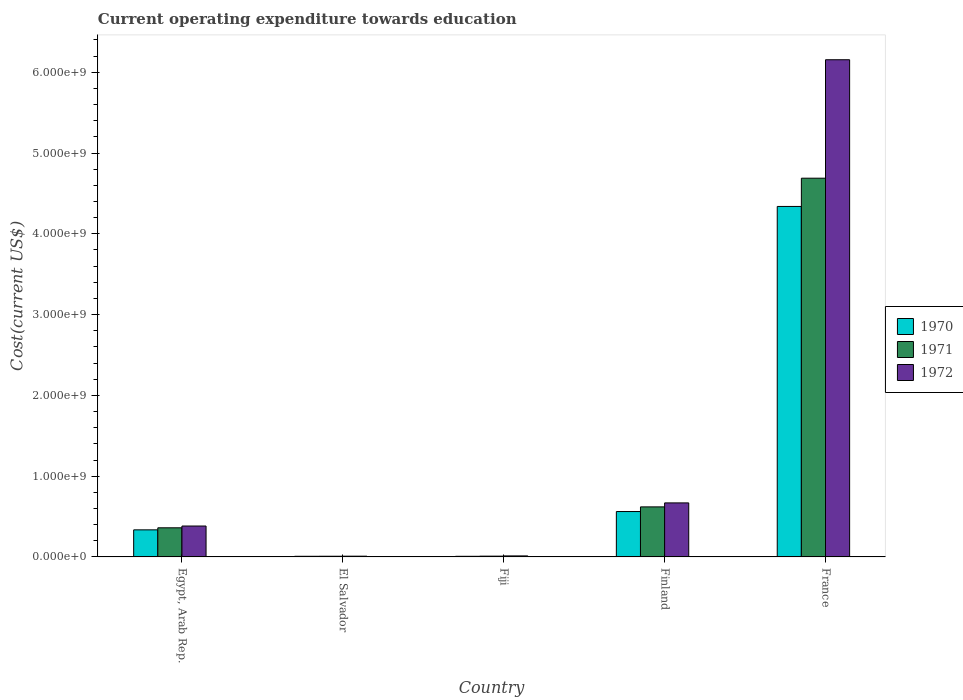How many different coloured bars are there?
Provide a short and direct response. 3. Are the number of bars on each tick of the X-axis equal?
Your answer should be very brief. Yes. What is the label of the 3rd group of bars from the left?
Offer a very short reply. Fiji. In how many cases, is the number of bars for a given country not equal to the number of legend labels?
Keep it short and to the point. 0. What is the expenditure towards education in 1970 in Fiji?
Provide a short and direct response. 7.79e+06. Across all countries, what is the maximum expenditure towards education in 1972?
Ensure brevity in your answer.  6.16e+09. Across all countries, what is the minimum expenditure towards education in 1972?
Give a very brief answer. 9.26e+06. In which country was the expenditure towards education in 1971 minimum?
Your response must be concise. El Salvador. What is the total expenditure towards education in 1972 in the graph?
Ensure brevity in your answer.  7.23e+09. What is the difference between the expenditure towards education in 1970 in Egypt, Arab Rep. and that in France?
Offer a very short reply. -4.00e+09. What is the difference between the expenditure towards education in 1972 in France and the expenditure towards education in 1970 in Finland?
Provide a short and direct response. 5.59e+09. What is the average expenditure towards education in 1970 per country?
Keep it short and to the point. 1.05e+09. What is the difference between the expenditure towards education of/in 1972 and expenditure towards education of/in 1971 in Fiji?
Offer a terse response. 2.95e+06. What is the ratio of the expenditure towards education in 1970 in Finland to that in France?
Your response must be concise. 0.13. What is the difference between the highest and the second highest expenditure towards education in 1970?
Provide a short and direct response. 3.78e+09. What is the difference between the highest and the lowest expenditure towards education in 1971?
Offer a terse response. 4.68e+09. In how many countries, is the expenditure towards education in 1972 greater than the average expenditure towards education in 1972 taken over all countries?
Your answer should be compact. 1. Is the sum of the expenditure towards education in 1972 in Finland and France greater than the maximum expenditure towards education in 1970 across all countries?
Make the answer very short. Yes. What does the 1st bar from the left in Egypt, Arab Rep. represents?
Your response must be concise. 1970. Is it the case that in every country, the sum of the expenditure towards education in 1970 and expenditure towards education in 1971 is greater than the expenditure towards education in 1972?
Keep it short and to the point. Yes. How many bars are there?
Offer a very short reply. 15. What is the difference between two consecutive major ticks on the Y-axis?
Your answer should be very brief. 1.00e+09. Are the values on the major ticks of Y-axis written in scientific E-notation?
Ensure brevity in your answer.  Yes. Does the graph contain grids?
Provide a short and direct response. No. Where does the legend appear in the graph?
Your answer should be very brief. Center right. What is the title of the graph?
Make the answer very short. Current operating expenditure towards education. What is the label or title of the Y-axis?
Give a very brief answer. Cost(current US$). What is the Cost(current US$) in 1970 in Egypt, Arab Rep.?
Give a very brief answer. 3.35e+08. What is the Cost(current US$) of 1971 in Egypt, Arab Rep.?
Keep it short and to the point. 3.60e+08. What is the Cost(current US$) in 1972 in Egypt, Arab Rep.?
Provide a succinct answer. 3.83e+08. What is the Cost(current US$) of 1970 in El Salvador?
Your response must be concise. 7.86e+06. What is the Cost(current US$) of 1971 in El Salvador?
Offer a terse response. 8.46e+06. What is the Cost(current US$) in 1972 in El Salvador?
Keep it short and to the point. 9.26e+06. What is the Cost(current US$) of 1970 in Fiji?
Keep it short and to the point. 7.79e+06. What is the Cost(current US$) of 1971 in Fiji?
Provide a succinct answer. 9.67e+06. What is the Cost(current US$) in 1972 in Fiji?
Make the answer very short. 1.26e+07. What is the Cost(current US$) of 1970 in Finland?
Make the answer very short. 5.62e+08. What is the Cost(current US$) in 1971 in Finland?
Make the answer very short. 6.20e+08. What is the Cost(current US$) of 1972 in Finland?
Your answer should be very brief. 6.69e+08. What is the Cost(current US$) in 1970 in France?
Offer a very short reply. 4.34e+09. What is the Cost(current US$) of 1971 in France?
Provide a short and direct response. 4.69e+09. What is the Cost(current US$) of 1972 in France?
Keep it short and to the point. 6.16e+09. Across all countries, what is the maximum Cost(current US$) of 1970?
Provide a succinct answer. 4.34e+09. Across all countries, what is the maximum Cost(current US$) of 1971?
Make the answer very short. 4.69e+09. Across all countries, what is the maximum Cost(current US$) of 1972?
Give a very brief answer. 6.16e+09. Across all countries, what is the minimum Cost(current US$) in 1970?
Provide a short and direct response. 7.79e+06. Across all countries, what is the minimum Cost(current US$) in 1971?
Your answer should be compact. 8.46e+06. Across all countries, what is the minimum Cost(current US$) of 1972?
Offer a terse response. 9.26e+06. What is the total Cost(current US$) in 1970 in the graph?
Offer a terse response. 5.25e+09. What is the total Cost(current US$) of 1971 in the graph?
Provide a short and direct response. 5.69e+09. What is the total Cost(current US$) of 1972 in the graph?
Offer a very short reply. 7.23e+09. What is the difference between the Cost(current US$) in 1970 in Egypt, Arab Rep. and that in El Salvador?
Make the answer very short. 3.27e+08. What is the difference between the Cost(current US$) in 1971 in Egypt, Arab Rep. and that in El Salvador?
Make the answer very short. 3.52e+08. What is the difference between the Cost(current US$) in 1972 in Egypt, Arab Rep. and that in El Salvador?
Keep it short and to the point. 3.73e+08. What is the difference between the Cost(current US$) of 1970 in Egypt, Arab Rep. and that in Fiji?
Your answer should be very brief. 3.27e+08. What is the difference between the Cost(current US$) of 1971 in Egypt, Arab Rep. and that in Fiji?
Give a very brief answer. 3.51e+08. What is the difference between the Cost(current US$) in 1972 in Egypt, Arab Rep. and that in Fiji?
Provide a short and direct response. 3.70e+08. What is the difference between the Cost(current US$) of 1970 in Egypt, Arab Rep. and that in Finland?
Your response must be concise. -2.27e+08. What is the difference between the Cost(current US$) of 1971 in Egypt, Arab Rep. and that in Finland?
Offer a terse response. -2.59e+08. What is the difference between the Cost(current US$) in 1972 in Egypt, Arab Rep. and that in Finland?
Offer a terse response. -2.86e+08. What is the difference between the Cost(current US$) of 1970 in Egypt, Arab Rep. and that in France?
Give a very brief answer. -4.00e+09. What is the difference between the Cost(current US$) in 1971 in Egypt, Arab Rep. and that in France?
Your answer should be very brief. -4.33e+09. What is the difference between the Cost(current US$) in 1972 in Egypt, Arab Rep. and that in France?
Your answer should be very brief. -5.77e+09. What is the difference between the Cost(current US$) of 1970 in El Salvador and that in Fiji?
Offer a very short reply. 7.56e+04. What is the difference between the Cost(current US$) of 1971 in El Salvador and that in Fiji?
Your response must be concise. -1.21e+06. What is the difference between the Cost(current US$) in 1972 in El Salvador and that in Fiji?
Ensure brevity in your answer.  -3.37e+06. What is the difference between the Cost(current US$) of 1970 in El Salvador and that in Finland?
Your answer should be very brief. -5.54e+08. What is the difference between the Cost(current US$) in 1971 in El Salvador and that in Finland?
Make the answer very short. -6.11e+08. What is the difference between the Cost(current US$) in 1972 in El Salvador and that in Finland?
Your answer should be very brief. -6.60e+08. What is the difference between the Cost(current US$) of 1970 in El Salvador and that in France?
Your answer should be compact. -4.33e+09. What is the difference between the Cost(current US$) of 1971 in El Salvador and that in France?
Your answer should be very brief. -4.68e+09. What is the difference between the Cost(current US$) in 1972 in El Salvador and that in France?
Your answer should be very brief. -6.15e+09. What is the difference between the Cost(current US$) of 1970 in Fiji and that in Finland?
Make the answer very short. -5.54e+08. What is the difference between the Cost(current US$) in 1971 in Fiji and that in Finland?
Ensure brevity in your answer.  -6.10e+08. What is the difference between the Cost(current US$) in 1972 in Fiji and that in Finland?
Ensure brevity in your answer.  -6.56e+08. What is the difference between the Cost(current US$) of 1970 in Fiji and that in France?
Keep it short and to the point. -4.33e+09. What is the difference between the Cost(current US$) in 1971 in Fiji and that in France?
Ensure brevity in your answer.  -4.68e+09. What is the difference between the Cost(current US$) of 1972 in Fiji and that in France?
Your answer should be very brief. -6.14e+09. What is the difference between the Cost(current US$) of 1970 in Finland and that in France?
Provide a succinct answer. -3.78e+09. What is the difference between the Cost(current US$) of 1971 in Finland and that in France?
Provide a short and direct response. -4.07e+09. What is the difference between the Cost(current US$) in 1972 in Finland and that in France?
Ensure brevity in your answer.  -5.49e+09. What is the difference between the Cost(current US$) in 1970 in Egypt, Arab Rep. and the Cost(current US$) in 1971 in El Salvador?
Keep it short and to the point. 3.27e+08. What is the difference between the Cost(current US$) of 1970 in Egypt, Arab Rep. and the Cost(current US$) of 1972 in El Salvador?
Provide a succinct answer. 3.26e+08. What is the difference between the Cost(current US$) in 1971 in Egypt, Arab Rep. and the Cost(current US$) in 1972 in El Salvador?
Keep it short and to the point. 3.51e+08. What is the difference between the Cost(current US$) of 1970 in Egypt, Arab Rep. and the Cost(current US$) of 1971 in Fiji?
Make the answer very short. 3.26e+08. What is the difference between the Cost(current US$) of 1970 in Egypt, Arab Rep. and the Cost(current US$) of 1972 in Fiji?
Make the answer very short. 3.23e+08. What is the difference between the Cost(current US$) of 1971 in Egypt, Arab Rep. and the Cost(current US$) of 1972 in Fiji?
Provide a succinct answer. 3.48e+08. What is the difference between the Cost(current US$) in 1970 in Egypt, Arab Rep. and the Cost(current US$) in 1971 in Finland?
Keep it short and to the point. -2.84e+08. What is the difference between the Cost(current US$) of 1970 in Egypt, Arab Rep. and the Cost(current US$) of 1972 in Finland?
Provide a succinct answer. -3.34e+08. What is the difference between the Cost(current US$) of 1971 in Egypt, Arab Rep. and the Cost(current US$) of 1972 in Finland?
Your answer should be compact. -3.08e+08. What is the difference between the Cost(current US$) of 1970 in Egypt, Arab Rep. and the Cost(current US$) of 1971 in France?
Provide a succinct answer. -4.35e+09. What is the difference between the Cost(current US$) in 1970 in Egypt, Arab Rep. and the Cost(current US$) in 1972 in France?
Give a very brief answer. -5.82e+09. What is the difference between the Cost(current US$) in 1971 in Egypt, Arab Rep. and the Cost(current US$) in 1972 in France?
Your answer should be compact. -5.79e+09. What is the difference between the Cost(current US$) in 1970 in El Salvador and the Cost(current US$) in 1971 in Fiji?
Ensure brevity in your answer.  -1.81e+06. What is the difference between the Cost(current US$) in 1970 in El Salvador and the Cost(current US$) in 1972 in Fiji?
Provide a succinct answer. -4.76e+06. What is the difference between the Cost(current US$) of 1971 in El Salvador and the Cost(current US$) of 1972 in Fiji?
Ensure brevity in your answer.  -4.16e+06. What is the difference between the Cost(current US$) of 1970 in El Salvador and the Cost(current US$) of 1971 in Finland?
Your answer should be very brief. -6.12e+08. What is the difference between the Cost(current US$) in 1970 in El Salvador and the Cost(current US$) in 1972 in Finland?
Your answer should be very brief. -6.61e+08. What is the difference between the Cost(current US$) in 1971 in El Salvador and the Cost(current US$) in 1972 in Finland?
Provide a short and direct response. -6.60e+08. What is the difference between the Cost(current US$) in 1970 in El Salvador and the Cost(current US$) in 1971 in France?
Keep it short and to the point. -4.68e+09. What is the difference between the Cost(current US$) of 1970 in El Salvador and the Cost(current US$) of 1972 in France?
Offer a terse response. -6.15e+09. What is the difference between the Cost(current US$) in 1971 in El Salvador and the Cost(current US$) in 1972 in France?
Make the answer very short. -6.15e+09. What is the difference between the Cost(current US$) of 1970 in Fiji and the Cost(current US$) of 1971 in Finland?
Provide a short and direct response. -6.12e+08. What is the difference between the Cost(current US$) of 1970 in Fiji and the Cost(current US$) of 1972 in Finland?
Offer a terse response. -6.61e+08. What is the difference between the Cost(current US$) of 1971 in Fiji and the Cost(current US$) of 1972 in Finland?
Make the answer very short. -6.59e+08. What is the difference between the Cost(current US$) of 1970 in Fiji and the Cost(current US$) of 1971 in France?
Offer a very short reply. -4.68e+09. What is the difference between the Cost(current US$) of 1970 in Fiji and the Cost(current US$) of 1972 in France?
Your response must be concise. -6.15e+09. What is the difference between the Cost(current US$) in 1971 in Fiji and the Cost(current US$) in 1972 in France?
Your answer should be compact. -6.15e+09. What is the difference between the Cost(current US$) of 1970 in Finland and the Cost(current US$) of 1971 in France?
Your response must be concise. -4.13e+09. What is the difference between the Cost(current US$) in 1970 in Finland and the Cost(current US$) in 1972 in France?
Provide a short and direct response. -5.59e+09. What is the difference between the Cost(current US$) in 1971 in Finland and the Cost(current US$) in 1972 in France?
Keep it short and to the point. -5.54e+09. What is the average Cost(current US$) in 1970 per country?
Your answer should be very brief. 1.05e+09. What is the average Cost(current US$) of 1971 per country?
Offer a very short reply. 1.14e+09. What is the average Cost(current US$) of 1972 per country?
Offer a terse response. 1.45e+09. What is the difference between the Cost(current US$) of 1970 and Cost(current US$) of 1971 in Egypt, Arab Rep.?
Your answer should be very brief. -2.53e+07. What is the difference between the Cost(current US$) of 1970 and Cost(current US$) of 1972 in Egypt, Arab Rep.?
Your response must be concise. -4.74e+07. What is the difference between the Cost(current US$) in 1971 and Cost(current US$) in 1972 in Egypt, Arab Rep.?
Ensure brevity in your answer.  -2.21e+07. What is the difference between the Cost(current US$) of 1970 and Cost(current US$) of 1971 in El Salvador?
Your response must be concise. -6.00e+05. What is the difference between the Cost(current US$) of 1970 and Cost(current US$) of 1972 in El Salvador?
Give a very brief answer. -1.39e+06. What is the difference between the Cost(current US$) in 1971 and Cost(current US$) in 1972 in El Salvador?
Your response must be concise. -7.94e+05. What is the difference between the Cost(current US$) in 1970 and Cost(current US$) in 1971 in Fiji?
Your response must be concise. -1.89e+06. What is the difference between the Cost(current US$) of 1970 and Cost(current US$) of 1972 in Fiji?
Your response must be concise. -4.84e+06. What is the difference between the Cost(current US$) of 1971 and Cost(current US$) of 1972 in Fiji?
Your response must be concise. -2.95e+06. What is the difference between the Cost(current US$) of 1970 and Cost(current US$) of 1971 in Finland?
Give a very brief answer. -5.76e+07. What is the difference between the Cost(current US$) in 1970 and Cost(current US$) in 1972 in Finland?
Provide a succinct answer. -1.07e+08. What is the difference between the Cost(current US$) in 1971 and Cost(current US$) in 1972 in Finland?
Your answer should be very brief. -4.93e+07. What is the difference between the Cost(current US$) of 1970 and Cost(current US$) of 1971 in France?
Give a very brief answer. -3.50e+08. What is the difference between the Cost(current US$) in 1970 and Cost(current US$) in 1972 in France?
Your response must be concise. -1.82e+09. What is the difference between the Cost(current US$) of 1971 and Cost(current US$) of 1972 in France?
Keep it short and to the point. -1.47e+09. What is the ratio of the Cost(current US$) of 1970 in Egypt, Arab Rep. to that in El Salvador?
Ensure brevity in your answer.  42.63. What is the ratio of the Cost(current US$) of 1971 in Egypt, Arab Rep. to that in El Salvador?
Ensure brevity in your answer.  42.59. What is the ratio of the Cost(current US$) in 1972 in Egypt, Arab Rep. to that in El Salvador?
Keep it short and to the point. 41.33. What is the ratio of the Cost(current US$) of 1970 in Egypt, Arab Rep. to that in Fiji?
Give a very brief answer. 43.04. What is the ratio of the Cost(current US$) in 1971 in Egypt, Arab Rep. to that in Fiji?
Your response must be concise. 37.26. What is the ratio of the Cost(current US$) of 1972 in Egypt, Arab Rep. to that in Fiji?
Offer a very short reply. 30.3. What is the ratio of the Cost(current US$) of 1970 in Egypt, Arab Rep. to that in Finland?
Offer a very short reply. 0.6. What is the ratio of the Cost(current US$) in 1971 in Egypt, Arab Rep. to that in Finland?
Your answer should be very brief. 0.58. What is the ratio of the Cost(current US$) in 1972 in Egypt, Arab Rep. to that in Finland?
Ensure brevity in your answer.  0.57. What is the ratio of the Cost(current US$) in 1970 in Egypt, Arab Rep. to that in France?
Give a very brief answer. 0.08. What is the ratio of the Cost(current US$) in 1971 in Egypt, Arab Rep. to that in France?
Make the answer very short. 0.08. What is the ratio of the Cost(current US$) of 1972 in Egypt, Arab Rep. to that in France?
Ensure brevity in your answer.  0.06. What is the ratio of the Cost(current US$) in 1970 in El Salvador to that in Fiji?
Keep it short and to the point. 1.01. What is the ratio of the Cost(current US$) of 1971 in El Salvador to that in Fiji?
Your answer should be compact. 0.87. What is the ratio of the Cost(current US$) of 1972 in El Salvador to that in Fiji?
Your response must be concise. 0.73. What is the ratio of the Cost(current US$) of 1970 in El Salvador to that in Finland?
Your answer should be very brief. 0.01. What is the ratio of the Cost(current US$) in 1971 in El Salvador to that in Finland?
Make the answer very short. 0.01. What is the ratio of the Cost(current US$) in 1972 in El Salvador to that in Finland?
Your answer should be compact. 0.01. What is the ratio of the Cost(current US$) in 1970 in El Salvador to that in France?
Offer a terse response. 0. What is the ratio of the Cost(current US$) in 1971 in El Salvador to that in France?
Keep it short and to the point. 0. What is the ratio of the Cost(current US$) in 1972 in El Salvador to that in France?
Provide a short and direct response. 0. What is the ratio of the Cost(current US$) in 1970 in Fiji to that in Finland?
Offer a very short reply. 0.01. What is the ratio of the Cost(current US$) in 1971 in Fiji to that in Finland?
Ensure brevity in your answer.  0.02. What is the ratio of the Cost(current US$) of 1972 in Fiji to that in Finland?
Provide a short and direct response. 0.02. What is the ratio of the Cost(current US$) in 1970 in Fiji to that in France?
Your response must be concise. 0. What is the ratio of the Cost(current US$) of 1971 in Fiji to that in France?
Keep it short and to the point. 0. What is the ratio of the Cost(current US$) in 1972 in Fiji to that in France?
Provide a short and direct response. 0. What is the ratio of the Cost(current US$) of 1970 in Finland to that in France?
Give a very brief answer. 0.13. What is the ratio of the Cost(current US$) in 1971 in Finland to that in France?
Your answer should be very brief. 0.13. What is the ratio of the Cost(current US$) of 1972 in Finland to that in France?
Make the answer very short. 0.11. What is the difference between the highest and the second highest Cost(current US$) of 1970?
Keep it short and to the point. 3.78e+09. What is the difference between the highest and the second highest Cost(current US$) of 1971?
Your response must be concise. 4.07e+09. What is the difference between the highest and the second highest Cost(current US$) in 1972?
Provide a short and direct response. 5.49e+09. What is the difference between the highest and the lowest Cost(current US$) in 1970?
Keep it short and to the point. 4.33e+09. What is the difference between the highest and the lowest Cost(current US$) in 1971?
Offer a terse response. 4.68e+09. What is the difference between the highest and the lowest Cost(current US$) in 1972?
Your answer should be compact. 6.15e+09. 